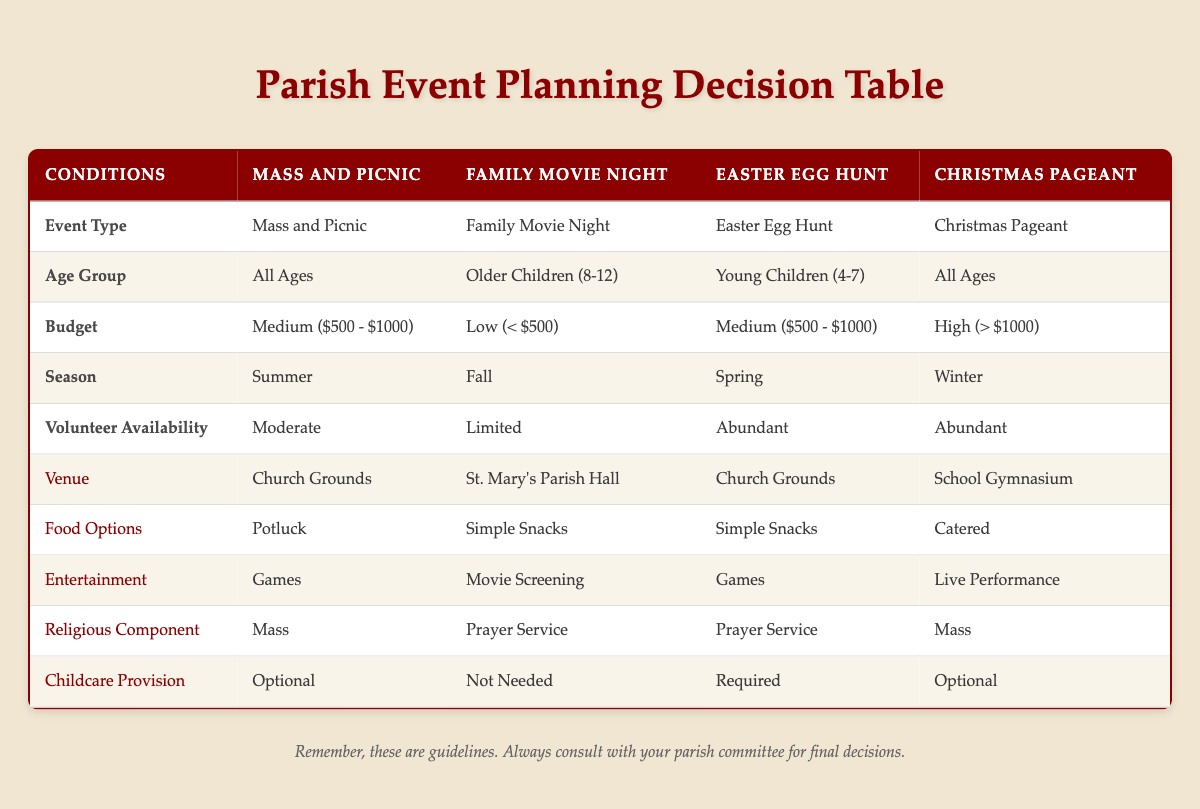What type of event has a medium budget and takes place in the summer? The table states that the "Mass and Picnic" event occurs in the summer with a medium budget of $500 to $1000.
Answer: Mass and Picnic Which venue is chosen for the Easter Egg Hunt? According to the table, the Easter Egg Hunt takes place at the "Church Grounds."
Answer: Church Grounds Is childcare provision required for the Family Movie Night? The table indicates that childcare provision for the Family Movie Night is marked as "Not Needed."
Answer: No What are the food options for the Christmas Pageant? The table shows that the food option for the Christmas Pageant is "Catered."
Answer: Catered How many events listed require an abundant level of volunteer availability? There are two events listed in the table (Easter Egg Hunt and Christmas Pageant) that require an abundant level of volunteer availability.
Answer: 2 For events targeted at "Toddlers (0-3)," which event is planned? The table indicates that none of the events specifically target "Toddlers (0-3)" group; hence, there are no events planned for that age group.
Answer: None If having a live performance is essential, which two events could be chosen? The table specifies that a live performance is part of the Christmas Pageant. No other event includes a live performance, making it the only option.
Answer: Christmas Pageant What is the average budget range for the events? The budget ranges for the four events are: medium (2 times), low (1 time), and high (1 time). The total budget values are (500-1000, 0-500, 500-1000, 1000+). To find the average: (750 + 250 + 750 + 1000) / 4 = 500.
Answer: Medium Which event is specifically designed for older children (8-12)? According to the table, the "Family Movie Night" is specifically designed for the older children age group.
Answer: Family Movie Night 